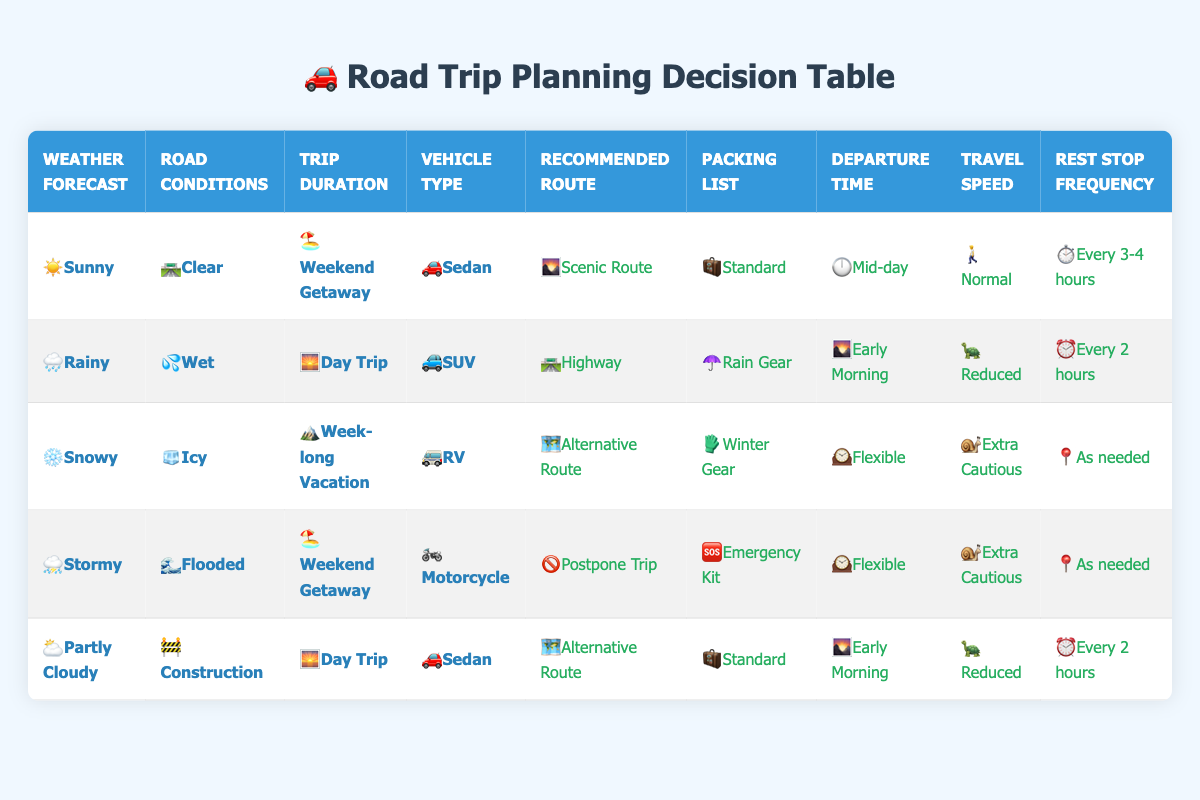What is the recommended route for a day trip in rainy weather using an SUV? In the table, we look for the row where the Trip Duration is "Day Trip," the Weather Forecast is "Rainy," and the Vehicle Type is "SUV." According to the second row, the recommended route is "Highway."
Answer: Highway What packing list is suggested for a snowy week-long vacation traveling in an RV? Check the row that lists "Week-long Vacation" under Trip Duration, "Snowy" under Weather Forecast, and "RV" under Vehicle Type. The third row indicates that the packing list should include "Winter Gear."
Answer: Winter Gear For a weekend getaway in stormy conditions on a motorcycle, what is the recommended action? We find the row that indicates "Weekend Getaway" for Trip Duration, "Stormy" for Weather Forecast, and "Motorcycle" for Vehicle Type. The fourth row tells us to "Postpone Trip."
Answer: Postpone Trip How frequently are rest stops recommended for a day trip in partly cloudy weather with construction on the road in a sedan? Look for the row where the Trip Duration is "Day Trip," the Weather Forecast is "Partly Cloudy," and the Vehicle Type is "Sedan." The last row indicates that rest stop frequency should be "Every 2 hours."
Answer: Every 2 hours What is the advised travel speed when going on a week-long vacation during snowy weather in an RV? We need to find the row for "Week-long Vacation" under Trip Duration, "Snowy" under Weather Forecast, and "RV" for Vehicle Type. The third row specifies the travel speed as "Extra Cautious."
Answer: Extra Cautious Is it true that traveling during a day trip in rainy conditions requires packing rain gear? To verify this, we find the row with "Day Trip" for Trip Duration and "Rainy" for Weather Forecast. The second row confirms that "Rain Gear" is required, making the statement true.
Answer: True If we combine conditions, what is the maximum recommended travel speed for any trip involving rainy weather? We look through the table for all rows where the Weather Forecast is "Rainy." The entries indicate a "Reduced" travel speed for rainy day trips in an SUV, which is the only applicable row. Thus, the maximum recommended travel speed in such cases is "Reduced."
Answer: Reduced What are the unique vehicle types mentioned for trips in snowy weather? In the table, we analyze the rows that have "Snowy" listed under Weather Forecast. The third row mentions "RV," which is the only vehicle type associated with snowy weather according to the data.
Answer: RV How many different recommended routes are suggested for a weekend getaway under various weather conditions? Checking each row with "Weekend Getaway" in Trip Duration, we find recommendations in the second row ("Scenic Route") and the fourth row ("Postpone Trip"). Therefore, there are two distinct recommended routes.
Answer: 2 